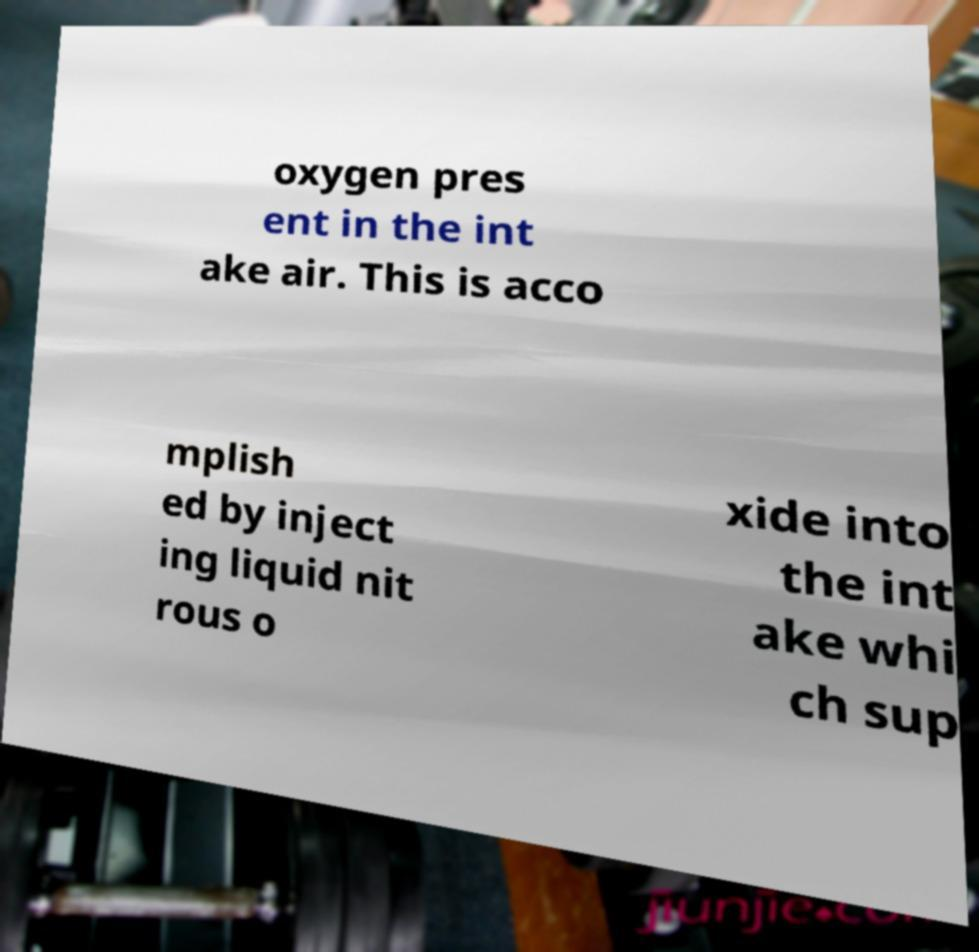I need the written content from this picture converted into text. Can you do that? oxygen pres ent in the int ake air. This is acco mplish ed by inject ing liquid nit rous o xide into the int ake whi ch sup 